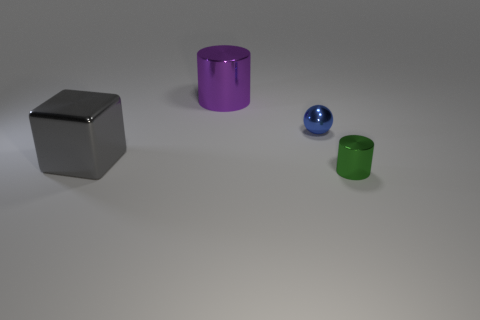Does the object that is to the right of the small blue metal thing have the same size as the cube that is behind the small green cylinder?
Keep it short and to the point. No. How many purple shiny cylinders are there?
Your response must be concise. 1. There is a gray shiny cube that is to the left of the metallic cylinder on the left side of the cylinder in front of the shiny cube; what is its size?
Keep it short and to the point. Large. Is the color of the tiny sphere the same as the large cube?
Offer a terse response. No. Are there any other things that have the same size as the ball?
Your answer should be compact. Yes. There is a large shiny cube; how many spheres are behind it?
Ensure brevity in your answer.  1. Is the number of big things on the left side of the gray object the same as the number of large brown rubber spheres?
Your response must be concise. Yes. What number of objects are rubber balls or tiny metallic things?
Your answer should be very brief. 2. Are there any other things that are the same shape as the gray shiny thing?
Provide a short and direct response. No. There is a metal object that is right of the small thing behind the tiny green cylinder; what is its shape?
Give a very brief answer. Cylinder. 